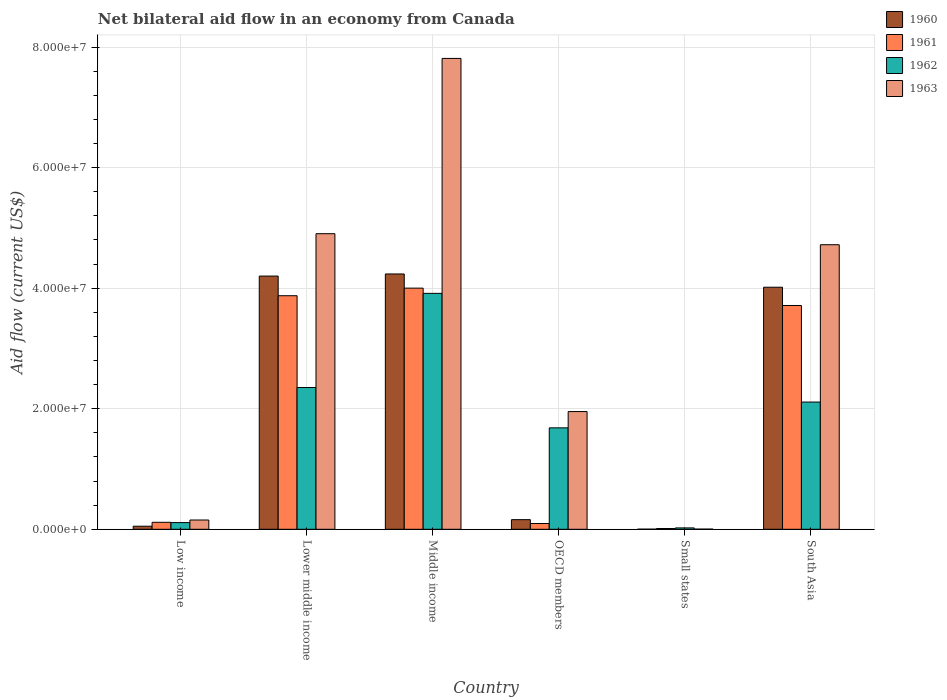How many different coloured bars are there?
Provide a short and direct response. 4. How many groups of bars are there?
Make the answer very short. 6. Are the number of bars per tick equal to the number of legend labels?
Ensure brevity in your answer.  Yes. How many bars are there on the 5th tick from the right?
Your answer should be very brief. 4. What is the label of the 4th group of bars from the left?
Give a very brief answer. OECD members. What is the net bilateral aid flow in 1963 in Low income?
Your response must be concise. 1.54e+06. Across all countries, what is the maximum net bilateral aid flow in 1963?
Give a very brief answer. 7.81e+07. In which country was the net bilateral aid flow in 1962 minimum?
Your response must be concise. Small states. What is the total net bilateral aid flow in 1960 in the graph?
Keep it short and to the point. 1.27e+08. What is the difference between the net bilateral aid flow in 1960 in Middle income and that in Small states?
Your answer should be compact. 4.23e+07. What is the difference between the net bilateral aid flow in 1962 in Lower middle income and the net bilateral aid flow in 1963 in OECD members?
Keep it short and to the point. 3.99e+06. What is the average net bilateral aid flow in 1963 per country?
Your answer should be very brief. 3.26e+07. What is the difference between the net bilateral aid flow of/in 1962 and net bilateral aid flow of/in 1960 in OECD members?
Offer a terse response. 1.52e+07. In how many countries, is the net bilateral aid flow in 1961 greater than 60000000 US$?
Offer a terse response. 0. What is the ratio of the net bilateral aid flow in 1963 in Low income to that in Lower middle income?
Offer a very short reply. 0.03. Is the net bilateral aid flow in 1962 in Low income less than that in South Asia?
Offer a terse response. Yes. What is the difference between the highest and the second highest net bilateral aid flow in 1961?
Ensure brevity in your answer.  2.88e+06. What is the difference between the highest and the lowest net bilateral aid flow in 1961?
Provide a succinct answer. 3.99e+07. In how many countries, is the net bilateral aid flow in 1963 greater than the average net bilateral aid flow in 1963 taken over all countries?
Provide a succinct answer. 3. Is the sum of the net bilateral aid flow in 1962 in Low income and Lower middle income greater than the maximum net bilateral aid flow in 1961 across all countries?
Provide a succinct answer. No. What does the 1st bar from the right in Middle income represents?
Give a very brief answer. 1963. Are the values on the major ticks of Y-axis written in scientific E-notation?
Provide a succinct answer. Yes. Does the graph contain grids?
Make the answer very short. Yes. Where does the legend appear in the graph?
Your response must be concise. Top right. How many legend labels are there?
Offer a very short reply. 4. What is the title of the graph?
Give a very brief answer. Net bilateral aid flow in an economy from Canada. Does "2014" appear as one of the legend labels in the graph?
Ensure brevity in your answer.  No. What is the label or title of the Y-axis?
Make the answer very short. Aid flow (current US$). What is the Aid flow (current US$) in 1960 in Low income?
Give a very brief answer. 5.10e+05. What is the Aid flow (current US$) of 1961 in Low income?
Your answer should be compact. 1.16e+06. What is the Aid flow (current US$) in 1962 in Low income?
Give a very brief answer. 1.11e+06. What is the Aid flow (current US$) of 1963 in Low income?
Provide a succinct answer. 1.54e+06. What is the Aid flow (current US$) of 1960 in Lower middle income?
Your answer should be compact. 4.20e+07. What is the Aid flow (current US$) of 1961 in Lower middle income?
Your response must be concise. 3.88e+07. What is the Aid flow (current US$) in 1962 in Lower middle income?
Offer a very short reply. 2.35e+07. What is the Aid flow (current US$) in 1963 in Lower middle income?
Make the answer very short. 4.90e+07. What is the Aid flow (current US$) of 1960 in Middle income?
Your response must be concise. 4.24e+07. What is the Aid flow (current US$) of 1961 in Middle income?
Your answer should be very brief. 4.00e+07. What is the Aid flow (current US$) of 1962 in Middle income?
Ensure brevity in your answer.  3.91e+07. What is the Aid flow (current US$) of 1963 in Middle income?
Provide a short and direct response. 7.81e+07. What is the Aid flow (current US$) in 1960 in OECD members?
Keep it short and to the point. 1.60e+06. What is the Aid flow (current US$) of 1961 in OECD members?
Offer a very short reply. 9.60e+05. What is the Aid flow (current US$) of 1962 in OECD members?
Offer a very short reply. 1.68e+07. What is the Aid flow (current US$) of 1963 in OECD members?
Provide a succinct answer. 1.95e+07. What is the Aid flow (current US$) in 1960 in Small states?
Offer a very short reply. 2.00e+04. What is the Aid flow (current US$) in 1960 in South Asia?
Give a very brief answer. 4.02e+07. What is the Aid flow (current US$) in 1961 in South Asia?
Offer a terse response. 3.71e+07. What is the Aid flow (current US$) in 1962 in South Asia?
Keep it short and to the point. 2.11e+07. What is the Aid flow (current US$) in 1963 in South Asia?
Provide a short and direct response. 4.72e+07. Across all countries, what is the maximum Aid flow (current US$) of 1960?
Make the answer very short. 4.24e+07. Across all countries, what is the maximum Aid flow (current US$) in 1961?
Offer a terse response. 4.00e+07. Across all countries, what is the maximum Aid flow (current US$) of 1962?
Offer a terse response. 3.91e+07. Across all countries, what is the maximum Aid flow (current US$) in 1963?
Your answer should be very brief. 7.81e+07. Across all countries, what is the minimum Aid flow (current US$) in 1960?
Ensure brevity in your answer.  2.00e+04. Across all countries, what is the minimum Aid flow (current US$) of 1962?
Keep it short and to the point. 2.30e+05. What is the total Aid flow (current US$) in 1960 in the graph?
Keep it short and to the point. 1.27e+08. What is the total Aid flow (current US$) in 1961 in the graph?
Provide a succinct answer. 1.18e+08. What is the total Aid flow (current US$) of 1962 in the graph?
Provide a short and direct response. 1.02e+08. What is the total Aid flow (current US$) of 1963 in the graph?
Your answer should be very brief. 1.95e+08. What is the difference between the Aid flow (current US$) of 1960 in Low income and that in Lower middle income?
Provide a succinct answer. -4.15e+07. What is the difference between the Aid flow (current US$) in 1961 in Low income and that in Lower middle income?
Provide a short and direct response. -3.76e+07. What is the difference between the Aid flow (current US$) of 1962 in Low income and that in Lower middle income?
Keep it short and to the point. -2.24e+07. What is the difference between the Aid flow (current US$) in 1963 in Low income and that in Lower middle income?
Keep it short and to the point. -4.75e+07. What is the difference between the Aid flow (current US$) in 1960 in Low income and that in Middle income?
Make the answer very short. -4.18e+07. What is the difference between the Aid flow (current US$) of 1961 in Low income and that in Middle income?
Provide a short and direct response. -3.88e+07. What is the difference between the Aid flow (current US$) of 1962 in Low income and that in Middle income?
Make the answer very short. -3.80e+07. What is the difference between the Aid flow (current US$) in 1963 in Low income and that in Middle income?
Offer a terse response. -7.66e+07. What is the difference between the Aid flow (current US$) in 1960 in Low income and that in OECD members?
Give a very brief answer. -1.09e+06. What is the difference between the Aid flow (current US$) in 1961 in Low income and that in OECD members?
Make the answer very short. 2.00e+05. What is the difference between the Aid flow (current US$) of 1962 in Low income and that in OECD members?
Give a very brief answer. -1.57e+07. What is the difference between the Aid flow (current US$) in 1963 in Low income and that in OECD members?
Ensure brevity in your answer.  -1.80e+07. What is the difference between the Aid flow (current US$) of 1960 in Low income and that in Small states?
Your answer should be very brief. 4.90e+05. What is the difference between the Aid flow (current US$) in 1961 in Low income and that in Small states?
Ensure brevity in your answer.  1.03e+06. What is the difference between the Aid flow (current US$) of 1962 in Low income and that in Small states?
Offer a very short reply. 8.80e+05. What is the difference between the Aid flow (current US$) in 1963 in Low income and that in Small states?
Your response must be concise. 1.51e+06. What is the difference between the Aid flow (current US$) in 1960 in Low income and that in South Asia?
Your answer should be compact. -3.96e+07. What is the difference between the Aid flow (current US$) of 1961 in Low income and that in South Asia?
Ensure brevity in your answer.  -3.60e+07. What is the difference between the Aid flow (current US$) of 1962 in Low income and that in South Asia?
Your answer should be very brief. -2.00e+07. What is the difference between the Aid flow (current US$) of 1963 in Low income and that in South Asia?
Offer a very short reply. -4.57e+07. What is the difference between the Aid flow (current US$) in 1960 in Lower middle income and that in Middle income?
Give a very brief answer. -3.50e+05. What is the difference between the Aid flow (current US$) of 1961 in Lower middle income and that in Middle income?
Your answer should be very brief. -1.26e+06. What is the difference between the Aid flow (current US$) of 1962 in Lower middle income and that in Middle income?
Provide a succinct answer. -1.56e+07. What is the difference between the Aid flow (current US$) in 1963 in Lower middle income and that in Middle income?
Offer a terse response. -2.91e+07. What is the difference between the Aid flow (current US$) of 1960 in Lower middle income and that in OECD members?
Your response must be concise. 4.04e+07. What is the difference between the Aid flow (current US$) in 1961 in Lower middle income and that in OECD members?
Make the answer very short. 3.78e+07. What is the difference between the Aid flow (current US$) of 1962 in Lower middle income and that in OECD members?
Your answer should be very brief. 6.69e+06. What is the difference between the Aid flow (current US$) in 1963 in Lower middle income and that in OECD members?
Provide a succinct answer. 2.95e+07. What is the difference between the Aid flow (current US$) of 1960 in Lower middle income and that in Small states?
Your answer should be very brief. 4.20e+07. What is the difference between the Aid flow (current US$) in 1961 in Lower middle income and that in Small states?
Ensure brevity in your answer.  3.86e+07. What is the difference between the Aid flow (current US$) in 1962 in Lower middle income and that in Small states?
Your answer should be very brief. 2.33e+07. What is the difference between the Aid flow (current US$) in 1963 in Lower middle income and that in Small states?
Your answer should be compact. 4.90e+07. What is the difference between the Aid flow (current US$) in 1960 in Lower middle income and that in South Asia?
Keep it short and to the point. 1.85e+06. What is the difference between the Aid flow (current US$) of 1961 in Lower middle income and that in South Asia?
Offer a terse response. 1.62e+06. What is the difference between the Aid flow (current US$) in 1962 in Lower middle income and that in South Asia?
Give a very brief answer. 2.41e+06. What is the difference between the Aid flow (current US$) of 1963 in Lower middle income and that in South Asia?
Keep it short and to the point. 1.83e+06. What is the difference between the Aid flow (current US$) of 1960 in Middle income and that in OECD members?
Provide a short and direct response. 4.08e+07. What is the difference between the Aid flow (current US$) of 1961 in Middle income and that in OECD members?
Your response must be concise. 3.90e+07. What is the difference between the Aid flow (current US$) in 1962 in Middle income and that in OECD members?
Give a very brief answer. 2.23e+07. What is the difference between the Aid flow (current US$) of 1963 in Middle income and that in OECD members?
Provide a short and direct response. 5.86e+07. What is the difference between the Aid flow (current US$) of 1960 in Middle income and that in Small states?
Give a very brief answer. 4.23e+07. What is the difference between the Aid flow (current US$) in 1961 in Middle income and that in Small states?
Offer a very short reply. 3.99e+07. What is the difference between the Aid flow (current US$) in 1962 in Middle income and that in Small states?
Your answer should be very brief. 3.89e+07. What is the difference between the Aid flow (current US$) of 1963 in Middle income and that in Small states?
Offer a very short reply. 7.81e+07. What is the difference between the Aid flow (current US$) of 1960 in Middle income and that in South Asia?
Your response must be concise. 2.20e+06. What is the difference between the Aid flow (current US$) of 1961 in Middle income and that in South Asia?
Offer a very short reply. 2.88e+06. What is the difference between the Aid flow (current US$) in 1962 in Middle income and that in South Asia?
Provide a short and direct response. 1.80e+07. What is the difference between the Aid flow (current US$) in 1963 in Middle income and that in South Asia?
Ensure brevity in your answer.  3.09e+07. What is the difference between the Aid flow (current US$) of 1960 in OECD members and that in Small states?
Your answer should be compact. 1.58e+06. What is the difference between the Aid flow (current US$) in 1961 in OECD members and that in Small states?
Your response must be concise. 8.30e+05. What is the difference between the Aid flow (current US$) of 1962 in OECD members and that in Small states?
Provide a short and direct response. 1.66e+07. What is the difference between the Aid flow (current US$) in 1963 in OECD members and that in Small states?
Your response must be concise. 1.95e+07. What is the difference between the Aid flow (current US$) in 1960 in OECD members and that in South Asia?
Make the answer very short. -3.86e+07. What is the difference between the Aid flow (current US$) of 1961 in OECD members and that in South Asia?
Your response must be concise. -3.62e+07. What is the difference between the Aid flow (current US$) in 1962 in OECD members and that in South Asia?
Ensure brevity in your answer.  -4.28e+06. What is the difference between the Aid flow (current US$) of 1963 in OECD members and that in South Asia?
Provide a succinct answer. -2.77e+07. What is the difference between the Aid flow (current US$) in 1960 in Small states and that in South Asia?
Offer a very short reply. -4.01e+07. What is the difference between the Aid flow (current US$) of 1961 in Small states and that in South Asia?
Give a very brief answer. -3.70e+07. What is the difference between the Aid flow (current US$) in 1962 in Small states and that in South Asia?
Your answer should be compact. -2.09e+07. What is the difference between the Aid flow (current US$) in 1963 in Small states and that in South Asia?
Offer a terse response. -4.72e+07. What is the difference between the Aid flow (current US$) of 1960 in Low income and the Aid flow (current US$) of 1961 in Lower middle income?
Your response must be concise. -3.82e+07. What is the difference between the Aid flow (current US$) in 1960 in Low income and the Aid flow (current US$) in 1962 in Lower middle income?
Ensure brevity in your answer.  -2.30e+07. What is the difference between the Aid flow (current US$) of 1960 in Low income and the Aid flow (current US$) of 1963 in Lower middle income?
Keep it short and to the point. -4.85e+07. What is the difference between the Aid flow (current US$) of 1961 in Low income and the Aid flow (current US$) of 1962 in Lower middle income?
Offer a terse response. -2.24e+07. What is the difference between the Aid flow (current US$) in 1961 in Low income and the Aid flow (current US$) in 1963 in Lower middle income?
Provide a short and direct response. -4.79e+07. What is the difference between the Aid flow (current US$) of 1962 in Low income and the Aid flow (current US$) of 1963 in Lower middle income?
Offer a terse response. -4.79e+07. What is the difference between the Aid flow (current US$) in 1960 in Low income and the Aid flow (current US$) in 1961 in Middle income?
Your response must be concise. -3.95e+07. What is the difference between the Aid flow (current US$) in 1960 in Low income and the Aid flow (current US$) in 1962 in Middle income?
Your answer should be very brief. -3.86e+07. What is the difference between the Aid flow (current US$) of 1960 in Low income and the Aid flow (current US$) of 1963 in Middle income?
Offer a terse response. -7.76e+07. What is the difference between the Aid flow (current US$) in 1961 in Low income and the Aid flow (current US$) in 1962 in Middle income?
Provide a succinct answer. -3.80e+07. What is the difference between the Aid flow (current US$) in 1961 in Low income and the Aid flow (current US$) in 1963 in Middle income?
Make the answer very short. -7.70e+07. What is the difference between the Aid flow (current US$) of 1962 in Low income and the Aid flow (current US$) of 1963 in Middle income?
Give a very brief answer. -7.70e+07. What is the difference between the Aid flow (current US$) of 1960 in Low income and the Aid flow (current US$) of 1961 in OECD members?
Provide a short and direct response. -4.50e+05. What is the difference between the Aid flow (current US$) of 1960 in Low income and the Aid flow (current US$) of 1962 in OECD members?
Keep it short and to the point. -1.63e+07. What is the difference between the Aid flow (current US$) in 1960 in Low income and the Aid flow (current US$) in 1963 in OECD members?
Keep it short and to the point. -1.90e+07. What is the difference between the Aid flow (current US$) of 1961 in Low income and the Aid flow (current US$) of 1962 in OECD members?
Your answer should be compact. -1.57e+07. What is the difference between the Aid flow (current US$) of 1961 in Low income and the Aid flow (current US$) of 1963 in OECD members?
Ensure brevity in your answer.  -1.84e+07. What is the difference between the Aid flow (current US$) in 1962 in Low income and the Aid flow (current US$) in 1963 in OECD members?
Your answer should be very brief. -1.84e+07. What is the difference between the Aid flow (current US$) in 1960 in Low income and the Aid flow (current US$) in 1962 in Small states?
Offer a very short reply. 2.80e+05. What is the difference between the Aid flow (current US$) in 1960 in Low income and the Aid flow (current US$) in 1963 in Small states?
Keep it short and to the point. 4.80e+05. What is the difference between the Aid flow (current US$) in 1961 in Low income and the Aid flow (current US$) in 1962 in Small states?
Ensure brevity in your answer.  9.30e+05. What is the difference between the Aid flow (current US$) of 1961 in Low income and the Aid flow (current US$) of 1963 in Small states?
Give a very brief answer. 1.13e+06. What is the difference between the Aid flow (current US$) of 1962 in Low income and the Aid flow (current US$) of 1963 in Small states?
Provide a short and direct response. 1.08e+06. What is the difference between the Aid flow (current US$) in 1960 in Low income and the Aid flow (current US$) in 1961 in South Asia?
Offer a terse response. -3.66e+07. What is the difference between the Aid flow (current US$) in 1960 in Low income and the Aid flow (current US$) in 1962 in South Asia?
Give a very brief answer. -2.06e+07. What is the difference between the Aid flow (current US$) of 1960 in Low income and the Aid flow (current US$) of 1963 in South Asia?
Your answer should be compact. -4.67e+07. What is the difference between the Aid flow (current US$) in 1961 in Low income and the Aid flow (current US$) in 1962 in South Asia?
Offer a terse response. -2.00e+07. What is the difference between the Aid flow (current US$) of 1961 in Low income and the Aid flow (current US$) of 1963 in South Asia?
Keep it short and to the point. -4.60e+07. What is the difference between the Aid flow (current US$) of 1962 in Low income and the Aid flow (current US$) of 1963 in South Asia?
Your answer should be compact. -4.61e+07. What is the difference between the Aid flow (current US$) in 1960 in Lower middle income and the Aid flow (current US$) in 1962 in Middle income?
Provide a succinct answer. 2.87e+06. What is the difference between the Aid flow (current US$) in 1960 in Lower middle income and the Aid flow (current US$) in 1963 in Middle income?
Offer a terse response. -3.61e+07. What is the difference between the Aid flow (current US$) of 1961 in Lower middle income and the Aid flow (current US$) of 1962 in Middle income?
Offer a terse response. -3.90e+05. What is the difference between the Aid flow (current US$) of 1961 in Lower middle income and the Aid flow (current US$) of 1963 in Middle income?
Make the answer very short. -3.94e+07. What is the difference between the Aid flow (current US$) in 1962 in Lower middle income and the Aid flow (current US$) in 1963 in Middle income?
Give a very brief answer. -5.46e+07. What is the difference between the Aid flow (current US$) in 1960 in Lower middle income and the Aid flow (current US$) in 1961 in OECD members?
Provide a short and direct response. 4.10e+07. What is the difference between the Aid flow (current US$) in 1960 in Lower middle income and the Aid flow (current US$) in 1962 in OECD members?
Keep it short and to the point. 2.52e+07. What is the difference between the Aid flow (current US$) in 1960 in Lower middle income and the Aid flow (current US$) in 1963 in OECD members?
Ensure brevity in your answer.  2.25e+07. What is the difference between the Aid flow (current US$) of 1961 in Lower middle income and the Aid flow (current US$) of 1962 in OECD members?
Your answer should be very brief. 2.19e+07. What is the difference between the Aid flow (current US$) of 1961 in Lower middle income and the Aid flow (current US$) of 1963 in OECD members?
Ensure brevity in your answer.  1.92e+07. What is the difference between the Aid flow (current US$) of 1962 in Lower middle income and the Aid flow (current US$) of 1963 in OECD members?
Offer a very short reply. 3.99e+06. What is the difference between the Aid flow (current US$) of 1960 in Lower middle income and the Aid flow (current US$) of 1961 in Small states?
Provide a short and direct response. 4.19e+07. What is the difference between the Aid flow (current US$) in 1960 in Lower middle income and the Aid flow (current US$) in 1962 in Small states?
Offer a very short reply. 4.18e+07. What is the difference between the Aid flow (current US$) in 1960 in Lower middle income and the Aid flow (current US$) in 1963 in Small states?
Provide a short and direct response. 4.20e+07. What is the difference between the Aid flow (current US$) of 1961 in Lower middle income and the Aid flow (current US$) of 1962 in Small states?
Ensure brevity in your answer.  3.85e+07. What is the difference between the Aid flow (current US$) of 1961 in Lower middle income and the Aid flow (current US$) of 1963 in Small states?
Your answer should be very brief. 3.87e+07. What is the difference between the Aid flow (current US$) of 1962 in Lower middle income and the Aid flow (current US$) of 1963 in Small states?
Your answer should be compact. 2.35e+07. What is the difference between the Aid flow (current US$) in 1960 in Lower middle income and the Aid flow (current US$) in 1961 in South Asia?
Provide a short and direct response. 4.88e+06. What is the difference between the Aid flow (current US$) of 1960 in Lower middle income and the Aid flow (current US$) of 1962 in South Asia?
Give a very brief answer. 2.09e+07. What is the difference between the Aid flow (current US$) of 1960 in Lower middle income and the Aid flow (current US$) of 1963 in South Asia?
Provide a short and direct response. -5.20e+06. What is the difference between the Aid flow (current US$) of 1961 in Lower middle income and the Aid flow (current US$) of 1962 in South Asia?
Offer a terse response. 1.76e+07. What is the difference between the Aid flow (current US$) in 1961 in Lower middle income and the Aid flow (current US$) in 1963 in South Asia?
Keep it short and to the point. -8.46e+06. What is the difference between the Aid flow (current US$) in 1962 in Lower middle income and the Aid flow (current US$) in 1963 in South Asia?
Your answer should be very brief. -2.37e+07. What is the difference between the Aid flow (current US$) of 1960 in Middle income and the Aid flow (current US$) of 1961 in OECD members?
Keep it short and to the point. 4.14e+07. What is the difference between the Aid flow (current US$) of 1960 in Middle income and the Aid flow (current US$) of 1962 in OECD members?
Offer a terse response. 2.55e+07. What is the difference between the Aid flow (current US$) of 1960 in Middle income and the Aid flow (current US$) of 1963 in OECD members?
Provide a short and direct response. 2.28e+07. What is the difference between the Aid flow (current US$) in 1961 in Middle income and the Aid flow (current US$) in 1962 in OECD members?
Offer a very short reply. 2.32e+07. What is the difference between the Aid flow (current US$) of 1961 in Middle income and the Aid flow (current US$) of 1963 in OECD members?
Give a very brief answer. 2.05e+07. What is the difference between the Aid flow (current US$) of 1962 in Middle income and the Aid flow (current US$) of 1963 in OECD members?
Keep it short and to the point. 1.96e+07. What is the difference between the Aid flow (current US$) in 1960 in Middle income and the Aid flow (current US$) in 1961 in Small states?
Provide a succinct answer. 4.22e+07. What is the difference between the Aid flow (current US$) in 1960 in Middle income and the Aid flow (current US$) in 1962 in Small states?
Provide a succinct answer. 4.21e+07. What is the difference between the Aid flow (current US$) in 1960 in Middle income and the Aid flow (current US$) in 1963 in Small states?
Ensure brevity in your answer.  4.23e+07. What is the difference between the Aid flow (current US$) in 1961 in Middle income and the Aid flow (current US$) in 1962 in Small states?
Offer a terse response. 3.98e+07. What is the difference between the Aid flow (current US$) of 1961 in Middle income and the Aid flow (current US$) of 1963 in Small states?
Ensure brevity in your answer.  4.00e+07. What is the difference between the Aid flow (current US$) in 1962 in Middle income and the Aid flow (current US$) in 1963 in Small states?
Your answer should be very brief. 3.91e+07. What is the difference between the Aid flow (current US$) in 1960 in Middle income and the Aid flow (current US$) in 1961 in South Asia?
Make the answer very short. 5.23e+06. What is the difference between the Aid flow (current US$) of 1960 in Middle income and the Aid flow (current US$) of 1962 in South Asia?
Ensure brevity in your answer.  2.12e+07. What is the difference between the Aid flow (current US$) in 1960 in Middle income and the Aid flow (current US$) in 1963 in South Asia?
Offer a very short reply. -4.85e+06. What is the difference between the Aid flow (current US$) of 1961 in Middle income and the Aid flow (current US$) of 1962 in South Asia?
Ensure brevity in your answer.  1.89e+07. What is the difference between the Aid flow (current US$) in 1961 in Middle income and the Aid flow (current US$) in 1963 in South Asia?
Ensure brevity in your answer.  -7.20e+06. What is the difference between the Aid flow (current US$) of 1962 in Middle income and the Aid flow (current US$) of 1963 in South Asia?
Your answer should be very brief. -8.07e+06. What is the difference between the Aid flow (current US$) of 1960 in OECD members and the Aid flow (current US$) of 1961 in Small states?
Provide a succinct answer. 1.47e+06. What is the difference between the Aid flow (current US$) in 1960 in OECD members and the Aid flow (current US$) in 1962 in Small states?
Keep it short and to the point. 1.37e+06. What is the difference between the Aid flow (current US$) in 1960 in OECD members and the Aid flow (current US$) in 1963 in Small states?
Your answer should be very brief. 1.57e+06. What is the difference between the Aid flow (current US$) in 1961 in OECD members and the Aid flow (current US$) in 1962 in Small states?
Your answer should be compact. 7.30e+05. What is the difference between the Aid flow (current US$) of 1961 in OECD members and the Aid flow (current US$) of 1963 in Small states?
Keep it short and to the point. 9.30e+05. What is the difference between the Aid flow (current US$) of 1962 in OECD members and the Aid flow (current US$) of 1963 in Small states?
Your answer should be compact. 1.68e+07. What is the difference between the Aid flow (current US$) of 1960 in OECD members and the Aid flow (current US$) of 1961 in South Asia?
Ensure brevity in your answer.  -3.55e+07. What is the difference between the Aid flow (current US$) in 1960 in OECD members and the Aid flow (current US$) in 1962 in South Asia?
Keep it short and to the point. -1.95e+07. What is the difference between the Aid flow (current US$) of 1960 in OECD members and the Aid flow (current US$) of 1963 in South Asia?
Offer a very short reply. -4.56e+07. What is the difference between the Aid flow (current US$) of 1961 in OECD members and the Aid flow (current US$) of 1962 in South Asia?
Your answer should be very brief. -2.02e+07. What is the difference between the Aid flow (current US$) in 1961 in OECD members and the Aid flow (current US$) in 1963 in South Asia?
Give a very brief answer. -4.62e+07. What is the difference between the Aid flow (current US$) in 1962 in OECD members and the Aid flow (current US$) in 1963 in South Asia?
Keep it short and to the point. -3.04e+07. What is the difference between the Aid flow (current US$) in 1960 in Small states and the Aid flow (current US$) in 1961 in South Asia?
Offer a terse response. -3.71e+07. What is the difference between the Aid flow (current US$) in 1960 in Small states and the Aid flow (current US$) in 1962 in South Asia?
Ensure brevity in your answer.  -2.11e+07. What is the difference between the Aid flow (current US$) in 1960 in Small states and the Aid flow (current US$) in 1963 in South Asia?
Your answer should be compact. -4.72e+07. What is the difference between the Aid flow (current US$) of 1961 in Small states and the Aid flow (current US$) of 1962 in South Asia?
Keep it short and to the point. -2.10e+07. What is the difference between the Aid flow (current US$) of 1961 in Small states and the Aid flow (current US$) of 1963 in South Asia?
Ensure brevity in your answer.  -4.71e+07. What is the difference between the Aid flow (current US$) in 1962 in Small states and the Aid flow (current US$) in 1963 in South Asia?
Your answer should be compact. -4.70e+07. What is the average Aid flow (current US$) of 1960 per country?
Offer a terse response. 2.11e+07. What is the average Aid flow (current US$) in 1961 per country?
Provide a succinct answer. 1.97e+07. What is the average Aid flow (current US$) of 1962 per country?
Your answer should be very brief. 1.70e+07. What is the average Aid flow (current US$) in 1963 per country?
Ensure brevity in your answer.  3.26e+07. What is the difference between the Aid flow (current US$) in 1960 and Aid flow (current US$) in 1961 in Low income?
Your response must be concise. -6.50e+05. What is the difference between the Aid flow (current US$) of 1960 and Aid flow (current US$) of 1962 in Low income?
Offer a very short reply. -6.00e+05. What is the difference between the Aid flow (current US$) in 1960 and Aid flow (current US$) in 1963 in Low income?
Offer a terse response. -1.03e+06. What is the difference between the Aid flow (current US$) in 1961 and Aid flow (current US$) in 1962 in Low income?
Ensure brevity in your answer.  5.00e+04. What is the difference between the Aid flow (current US$) in 1961 and Aid flow (current US$) in 1963 in Low income?
Your answer should be very brief. -3.80e+05. What is the difference between the Aid flow (current US$) of 1962 and Aid flow (current US$) of 1963 in Low income?
Offer a very short reply. -4.30e+05. What is the difference between the Aid flow (current US$) of 1960 and Aid flow (current US$) of 1961 in Lower middle income?
Make the answer very short. 3.26e+06. What is the difference between the Aid flow (current US$) of 1960 and Aid flow (current US$) of 1962 in Lower middle income?
Your answer should be very brief. 1.85e+07. What is the difference between the Aid flow (current US$) in 1960 and Aid flow (current US$) in 1963 in Lower middle income?
Provide a short and direct response. -7.03e+06. What is the difference between the Aid flow (current US$) of 1961 and Aid flow (current US$) of 1962 in Lower middle income?
Keep it short and to the point. 1.52e+07. What is the difference between the Aid flow (current US$) of 1961 and Aid flow (current US$) of 1963 in Lower middle income?
Keep it short and to the point. -1.03e+07. What is the difference between the Aid flow (current US$) of 1962 and Aid flow (current US$) of 1963 in Lower middle income?
Your answer should be very brief. -2.55e+07. What is the difference between the Aid flow (current US$) of 1960 and Aid flow (current US$) of 1961 in Middle income?
Keep it short and to the point. 2.35e+06. What is the difference between the Aid flow (current US$) of 1960 and Aid flow (current US$) of 1962 in Middle income?
Keep it short and to the point. 3.22e+06. What is the difference between the Aid flow (current US$) in 1960 and Aid flow (current US$) in 1963 in Middle income?
Your answer should be very brief. -3.58e+07. What is the difference between the Aid flow (current US$) of 1961 and Aid flow (current US$) of 1962 in Middle income?
Offer a very short reply. 8.70e+05. What is the difference between the Aid flow (current US$) in 1961 and Aid flow (current US$) in 1963 in Middle income?
Your response must be concise. -3.81e+07. What is the difference between the Aid flow (current US$) of 1962 and Aid flow (current US$) of 1963 in Middle income?
Keep it short and to the point. -3.90e+07. What is the difference between the Aid flow (current US$) of 1960 and Aid flow (current US$) of 1961 in OECD members?
Your response must be concise. 6.40e+05. What is the difference between the Aid flow (current US$) of 1960 and Aid flow (current US$) of 1962 in OECD members?
Provide a succinct answer. -1.52e+07. What is the difference between the Aid flow (current US$) in 1960 and Aid flow (current US$) in 1963 in OECD members?
Offer a terse response. -1.79e+07. What is the difference between the Aid flow (current US$) in 1961 and Aid flow (current US$) in 1962 in OECD members?
Offer a terse response. -1.59e+07. What is the difference between the Aid flow (current US$) in 1961 and Aid flow (current US$) in 1963 in OECD members?
Your answer should be compact. -1.86e+07. What is the difference between the Aid flow (current US$) of 1962 and Aid flow (current US$) of 1963 in OECD members?
Offer a very short reply. -2.70e+06. What is the difference between the Aid flow (current US$) in 1960 and Aid flow (current US$) in 1961 in Small states?
Your response must be concise. -1.10e+05. What is the difference between the Aid flow (current US$) of 1960 and Aid flow (current US$) of 1962 in Small states?
Make the answer very short. -2.10e+05. What is the difference between the Aid flow (current US$) of 1960 and Aid flow (current US$) of 1963 in Small states?
Provide a short and direct response. -10000. What is the difference between the Aid flow (current US$) in 1961 and Aid flow (current US$) in 1963 in Small states?
Keep it short and to the point. 1.00e+05. What is the difference between the Aid flow (current US$) in 1962 and Aid flow (current US$) in 1963 in Small states?
Offer a very short reply. 2.00e+05. What is the difference between the Aid flow (current US$) of 1960 and Aid flow (current US$) of 1961 in South Asia?
Your answer should be very brief. 3.03e+06. What is the difference between the Aid flow (current US$) of 1960 and Aid flow (current US$) of 1962 in South Asia?
Ensure brevity in your answer.  1.90e+07. What is the difference between the Aid flow (current US$) in 1960 and Aid flow (current US$) in 1963 in South Asia?
Your response must be concise. -7.05e+06. What is the difference between the Aid flow (current US$) of 1961 and Aid flow (current US$) of 1962 in South Asia?
Offer a very short reply. 1.60e+07. What is the difference between the Aid flow (current US$) of 1961 and Aid flow (current US$) of 1963 in South Asia?
Offer a very short reply. -1.01e+07. What is the difference between the Aid flow (current US$) in 1962 and Aid flow (current US$) in 1963 in South Asia?
Offer a terse response. -2.61e+07. What is the ratio of the Aid flow (current US$) of 1960 in Low income to that in Lower middle income?
Your answer should be very brief. 0.01. What is the ratio of the Aid flow (current US$) in 1961 in Low income to that in Lower middle income?
Offer a very short reply. 0.03. What is the ratio of the Aid flow (current US$) in 1962 in Low income to that in Lower middle income?
Offer a terse response. 0.05. What is the ratio of the Aid flow (current US$) in 1963 in Low income to that in Lower middle income?
Keep it short and to the point. 0.03. What is the ratio of the Aid flow (current US$) of 1960 in Low income to that in Middle income?
Ensure brevity in your answer.  0.01. What is the ratio of the Aid flow (current US$) of 1961 in Low income to that in Middle income?
Your answer should be very brief. 0.03. What is the ratio of the Aid flow (current US$) of 1962 in Low income to that in Middle income?
Make the answer very short. 0.03. What is the ratio of the Aid flow (current US$) of 1963 in Low income to that in Middle income?
Ensure brevity in your answer.  0.02. What is the ratio of the Aid flow (current US$) in 1960 in Low income to that in OECD members?
Your answer should be compact. 0.32. What is the ratio of the Aid flow (current US$) of 1961 in Low income to that in OECD members?
Offer a terse response. 1.21. What is the ratio of the Aid flow (current US$) of 1962 in Low income to that in OECD members?
Offer a terse response. 0.07. What is the ratio of the Aid flow (current US$) in 1963 in Low income to that in OECD members?
Offer a very short reply. 0.08. What is the ratio of the Aid flow (current US$) of 1960 in Low income to that in Small states?
Your answer should be very brief. 25.5. What is the ratio of the Aid flow (current US$) of 1961 in Low income to that in Small states?
Ensure brevity in your answer.  8.92. What is the ratio of the Aid flow (current US$) in 1962 in Low income to that in Small states?
Provide a short and direct response. 4.83. What is the ratio of the Aid flow (current US$) of 1963 in Low income to that in Small states?
Give a very brief answer. 51.33. What is the ratio of the Aid flow (current US$) of 1960 in Low income to that in South Asia?
Keep it short and to the point. 0.01. What is the ratio of the Aid flow (current US$) in 1961 in Low income to that in South Asia?
Offer a terse response. 0.03. What is the ratio of the Aid flow (current US$) in 1962 in Low income to that in South Asia?
Your response must be concise. 0.05. What is the ratio of the Aid flow (current US$) in 1963 in Low income to that in South Asia?
Ensure brevity in your answer.  0.03. What is the ratio of the Aid flow (current US$) of 1961 in Lower middle income to that in Middle income?
Ensure brevity in your answer.  0.97. What is the ratio of the Aid flow (current US$) in 1962 in Lower middle income to that in Middle income?
Your answer should be very brief. 0.6. What is the ratio of the Aid flow (current US$) of 1963 in Lower middle income to that in Middle income?
Give a very brief answer. 0.63. What is the ratio of the Aid flow (current US$) in 1960 in Lower middle income to that in OECD members?
Provide a succinct answer. 26.26. What is the ratio of the Aid flow (current US$) in 1961 in Lower middle income to that in OECD members?
Your response must be concise. 40.36. What is the ratio of the Aid flow (current US$) of 1962 in Lower middle income to that in OECD members?
Offer a very short reply. 1.4. What is the ratio of the Aid flow (current US$) of 1963 in Lower middle income to that in OECD members?
Keep it short and to the point. 2.51. What is the ratio of the Aid flow (current US$) of 1960 in Lower middle income to that in Small states?
Offer a very short reply. 2100.5. What is the ratio of the Aid flow (current US$) of 1961 in Lower middle income to that in Small states?
Your answer should be compact. 298.08. What is the ratio of the Aid flow (current US$) of 1962 in Lower middle income to that in Small states?
Keep it short and to the point. 102.26. What is the ratio of the Aid flow (current US$) of 1963 in Lower middle income to that in Small states?
Ensure brevity in your answer.  1634.67. What is the ratio of the Aid flow (current US$) of 1960 in Lower middle income to that in South Asia?
Your response must be concise. 1.05. What is the ratio of the Aid flow (current US$) in 1961 in Lower middle income to that in South Asia?
Give a very brief answer. 1.04. What is the ratio of the Aid flow (current US$) in 1962 in Lower middle income to that in South Asia?
Offer a very short reply. 1.11. What is the ratio of the Aid flow (current US$) in 1963 in Lower middle income to that in South Asia?
Your answer should be compact. 1.04. What is the ratio of the Aid flow (current US$) in 1960 in Middle income to that in OECD members?
Make the answer very short. 26.48. What is the ratio of the Aid flow (current US$) in 1961 in Middle income to that in OECD members?
Ensure brevity in your answer.  41.68. What is the ratio of the Aid flow (current US$) in 1962 in Middle income to that in OECD members?
Make the answer very short. 2.33. What is the ratio of the Aid flow (current US$) of 1960 in Middle income to that in Small states?
Provide a succinct answer. 2118. What is the ratio of the Aid flow (current US$) in 1961 in Middle income to that in Small states?
Ensure brevity in your answer.  307.77. What is the ratio of the Aid flow (current US$) in 1962 in Middle income to that in Small states?
Provide a succinct answer. 170.17. What is the ratio of the Aid flow (current US$) of 1963 in Middle income to that in Small states?
Your answer should be compact. 2604. What is the ratio of the Aid flow (current US$) of 1960 in Middle income to that in South Asia?
Give a very brief answer. 1.05. What is the ratio of the Aid flow (current US$) of 1961 in Middle income to that in South Asia?
Provide a short and direct response. 1.08. What is the ratio of the Aid flow (current US$) of 1962 in Middle income to that in South Asia?
Your response must be concise. 1.85. What is the ratio of the Aid flow (current US$) of 1963 in Middle income to that in South Asia?
Your answer should be very brief. 1.65. What is the ratio of the Aid flow (current US$) of 1961 in OECD members to that in Small states?
Provide a succinct answer. 7.38. What is the ratio of the Aid flow (current US$) of 1962 in OECD members to that in Small states?
Give a very brief answer. 73.17. What is the ratio of the Aid flow (current US$) in 1963 in OECD members to that in Small states?
Keep it short and to the point. 651. What is the ratio of the Aid flow (current US$) of 1960 in OECD members to that in South Asia?
Your response must be concise. 0.04. What is the ratio of the Aid flow (current US$) in 1961 in OECD members to that in South Asia?
Offer a very short reply. 0.03. What is the ratio of the Aid flow (current US$) of 1962 in OECD members to that in South Asia?
Give a very brief answer. 0.8. What is the ratio of the Aid flow (current US$) of 1963 in OECD members to that in South Asia?
Keep it short and to the point. 0.41. What is the ratio of the Aid flow (current US$) in 1961 in Small states to that in South Asia?
Provide a short and direct response. 0. What is the ratio of the Aid flow (current US$) in 1962 in Small states to that in South Asia?
Provide a succinct answer. 0.01. What is the ratio of the Aid flow (current US$) of 1963 in Small states to that in South Asia?
Provide a short and direct response. 0. What is the difference between the highest and the second highest Aid flow (current US$) in 1960?
Give a very brief answer. 3.50e+05. What is the difference between the highest and the second highest Aid flow (current US$) of 1961?
Offer a very short reply. 1.26e+06. What is the difference between the highest and the second highest Aid flow (current US$) in 1962?
Offer a very short reply. 1.56e+07. What is the difference between the highest and the second highest Aid flow (current US$) of 1963?
Give a very brief answer. 2.91e+07. What is the difference between the highest and the lowest Aid flow (current US$) in 1960?
Provide a short and direct response. 4.23e+07. What is the difference between the highest and the lowest Aid flow (current US$) in 1961?
Your answer should be very brief. 3.99e+07. What is the difference between the highest and the lowest Aid flow (current US$) of 1962?
Ensure brevity in your answer.  3.89e+07. What is the difference between the highest and the lowest Aid flow (current US$) of 1963?
Keep it short and to the point. 7.81e+07. 